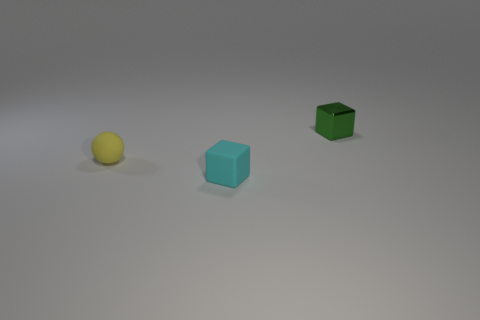Add 3 small red metal cylinders. How many objects exist? 6 Subtract all blocks. How many objects are left? 1 Subtract 0 purple cylinders. How many objects are left? 3 Subtract all rubber objects. Subtract all tiny blue objects. How many objects are left? 1 Add 3 tiny green metallic blocks. How many tiny green metallic blocks are left? 4 Add 3 blue metal cylinders. How many blue metal cylinders exist? 3 